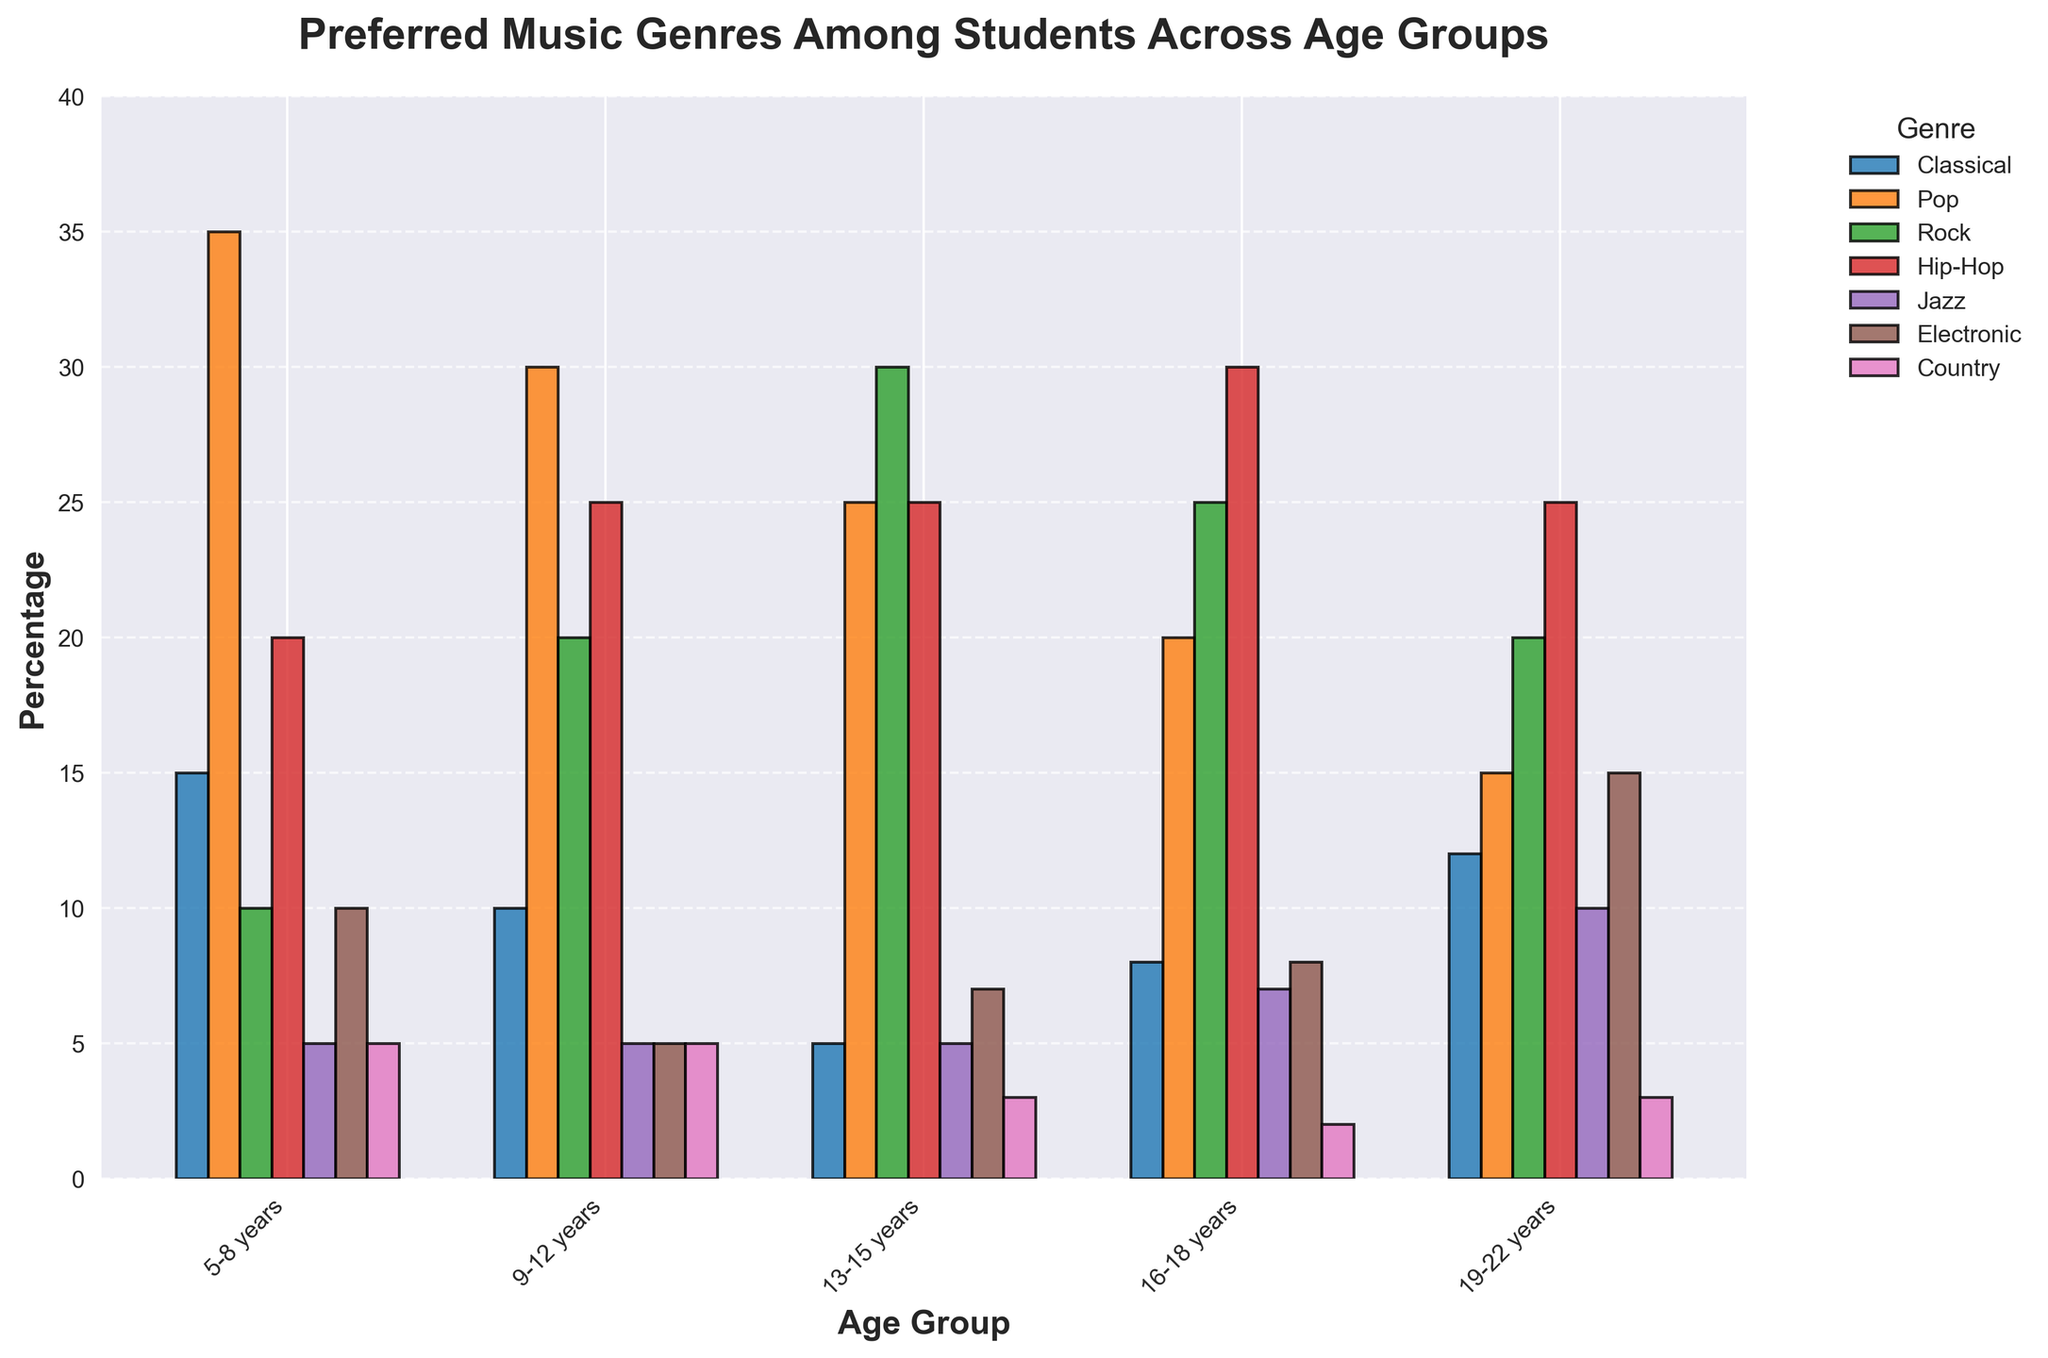Which age group prefers Rock the most? Looking at the bar heights for Rock across all age groups, the tallest bar belongs to the 13-15 years group.
Answer: 13-15 years Compare the preference for Classical music between the youngest and oldest age groups. The 5-8 years group has a bar height of 15 for Classical music, and the 19-22 years group has a bar height of 12. The 5-8 years group prefers Classical music slightly more.
Answer: 5-8 years What is the total preference percentage for Pop music across all age groups? Add the heights of the Pop bars for each age group: 35 + 30 + 25 + 20 + 15 = 125.
Answer: 125 Which genre has the least preference in the 16-18 years age group? For the 16-18 years group, the shortest bar is Country, with a height of 2.
Answer: Country Is Jazz more popular than Electronic in the 19-22 years age group? Compare the bar heights for Jazz (10) and Electronic (15) in the 19-22 years group. Electronic is more popular.
Answer: No What is the average preference for Hip-Hop across all age groups? Sum the Hip-Hop values: 20 + 25 + 25 + 30 + 25 = 125. Divide by the number of age groups (5). 125 / 5 = 25.
Answer: 25 Between the 9-12 years and 13-15 years groups, which one shows a higher preference for Jazz? Compare the bar heights for Jazz: 5 (9-12 years) and 5 (13-15 years). They are equal.
Answer: Equal What is the difference in preference for Country music between the 13-15 years group and the 19-22 years group? Subtract the Country value for 19-22 years (3) from that for 13-15 years (3). 3 - 3 = 0.
Answer: 0 Which age group shows the greatest preference for Hip-Hop? The tallest Hip-Hop bar is for the 16-18 years group with a height of 30.
Answer: 16-18 years 